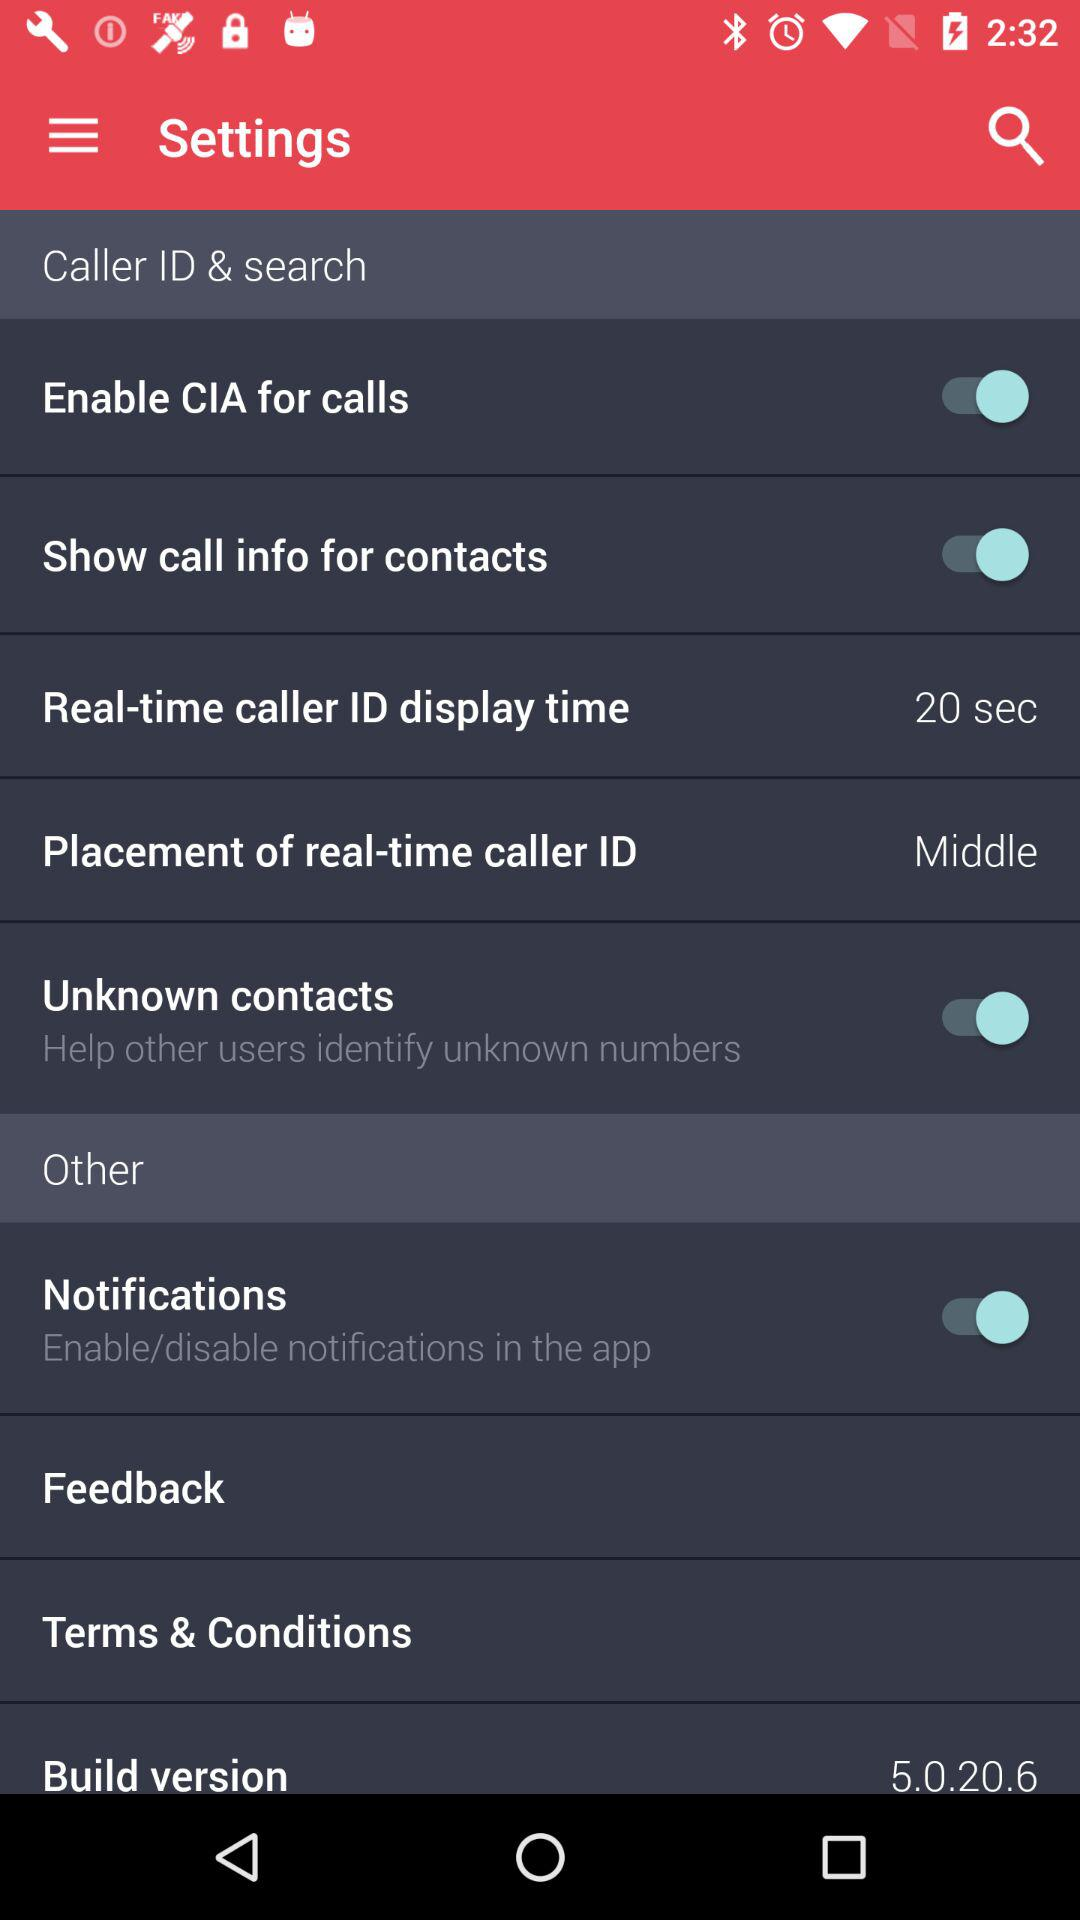What is the build version? The build version is 5.0.20.6. 